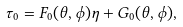<formula> <loc_0><loc_0><loc_500><loc_500>\tau _ { 0 } = F _ { 0 } ( \theta , \phi ) \eta + G _ { 0 } ( \theta , \phi ) ,</formula> 